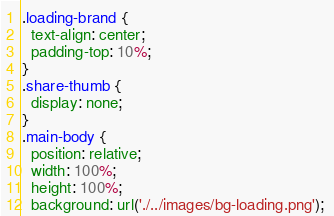Convert code to text. <code><loc_0><loc_0><loc_500><loc_500><_CSS_>.loading-brand {
  text-align: center;
  padding-top: 10%;
}
.share-thumb {
  display: none;
}
.main-body {
  position: relative; 
  width: 100%; 
  height: 100%;
  background: url('./../images/bg-loading.png'); </code> 